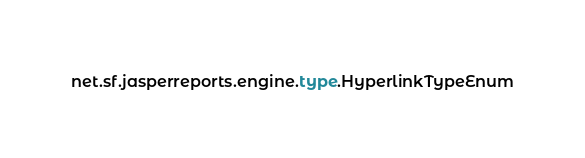Convert code to text. <code><loc_0><loc_0><loc_500><loc_500><_Rust_>net.sf.jasperreports.engine.type.HyperlinkTypeEnum
</code> 